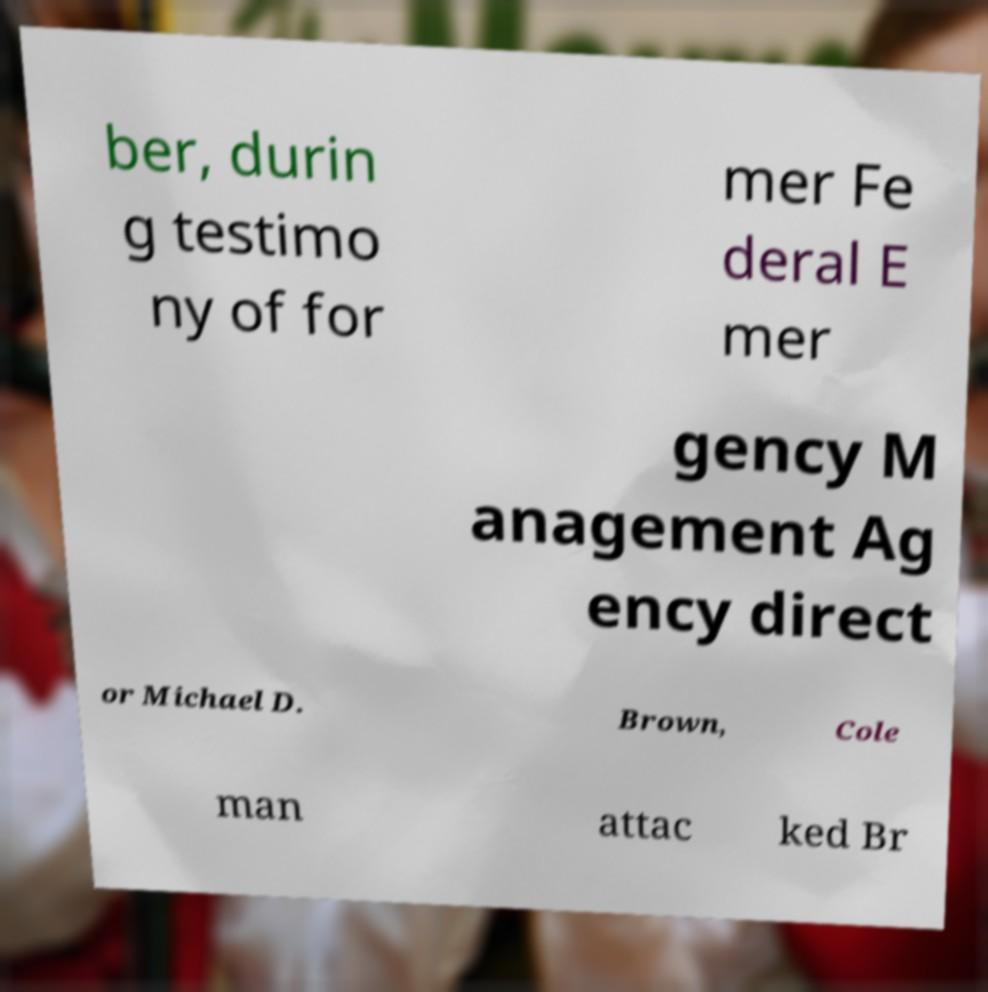Could you extract and type out the text from this image? ber, durin g testimo ny of for mer Fe deral E mer gency M anagement Ag ency direct or Michael D. Brown, Cole man attac ked Br 